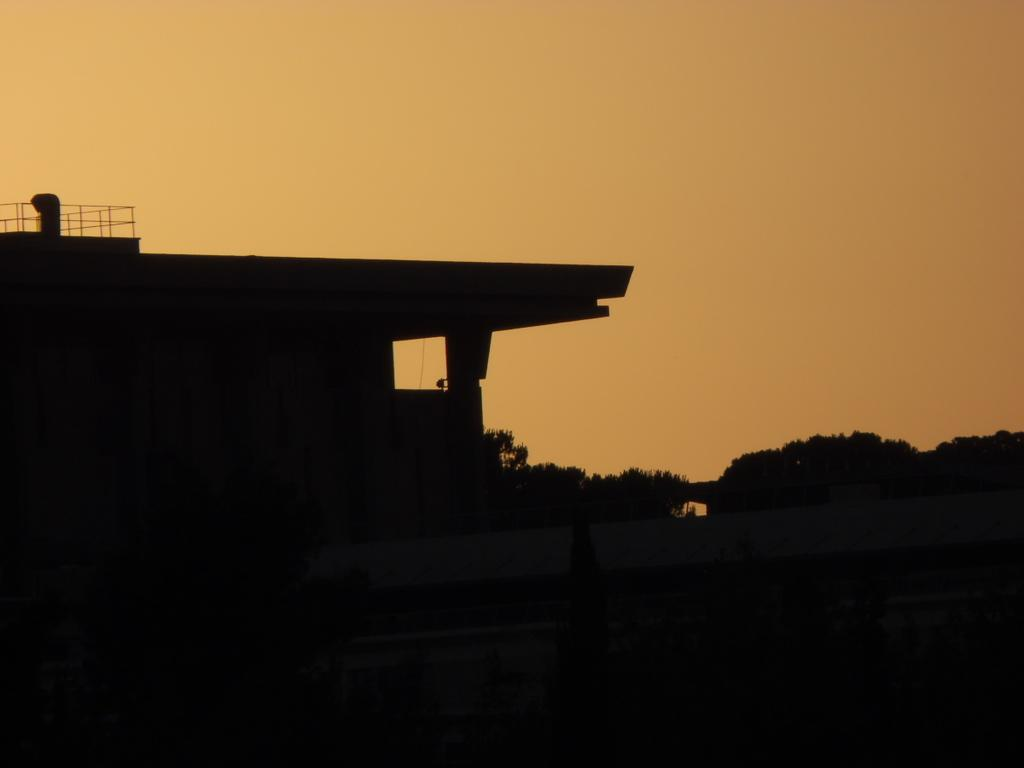What type of structure is present in the image? There is a building in the image. What can be seen in the background of the image? There are trees and plants in the image. What is visible on the ground in the image? There are objects on the ground in the image. What part of the natural environment is visible in the image? The ground and the sky are visible in the image. How many beds can be seen in the image? There are no beds present in the image. What type of error is visible in the image? There is no error present in the image. 